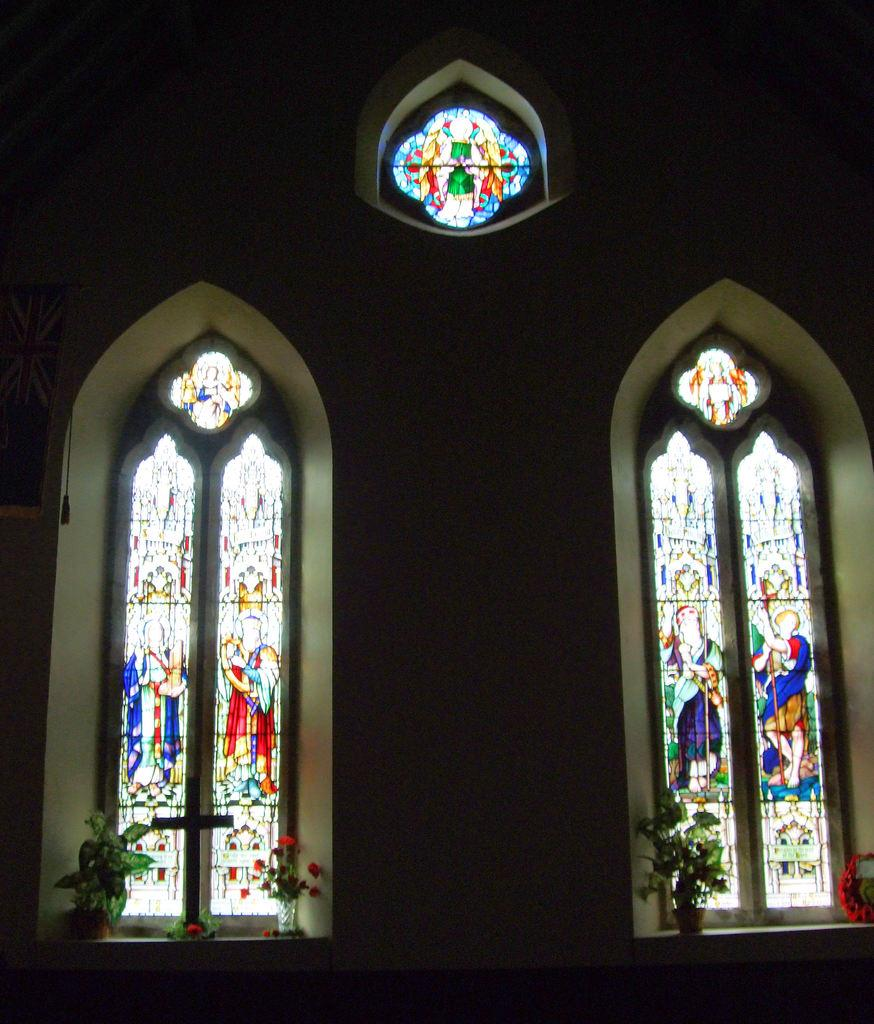What type of glass can be seen in the image? There are stained glasses in the image. What is located in the middle of the image? There is a wall in the middle of the image. What type of vegetation is present in the image? There are plants in plant pots on either side of the image. What type of lipstick is being used by the person in the image? There is no person present in the image, and therefore no lipstick or person using it. 